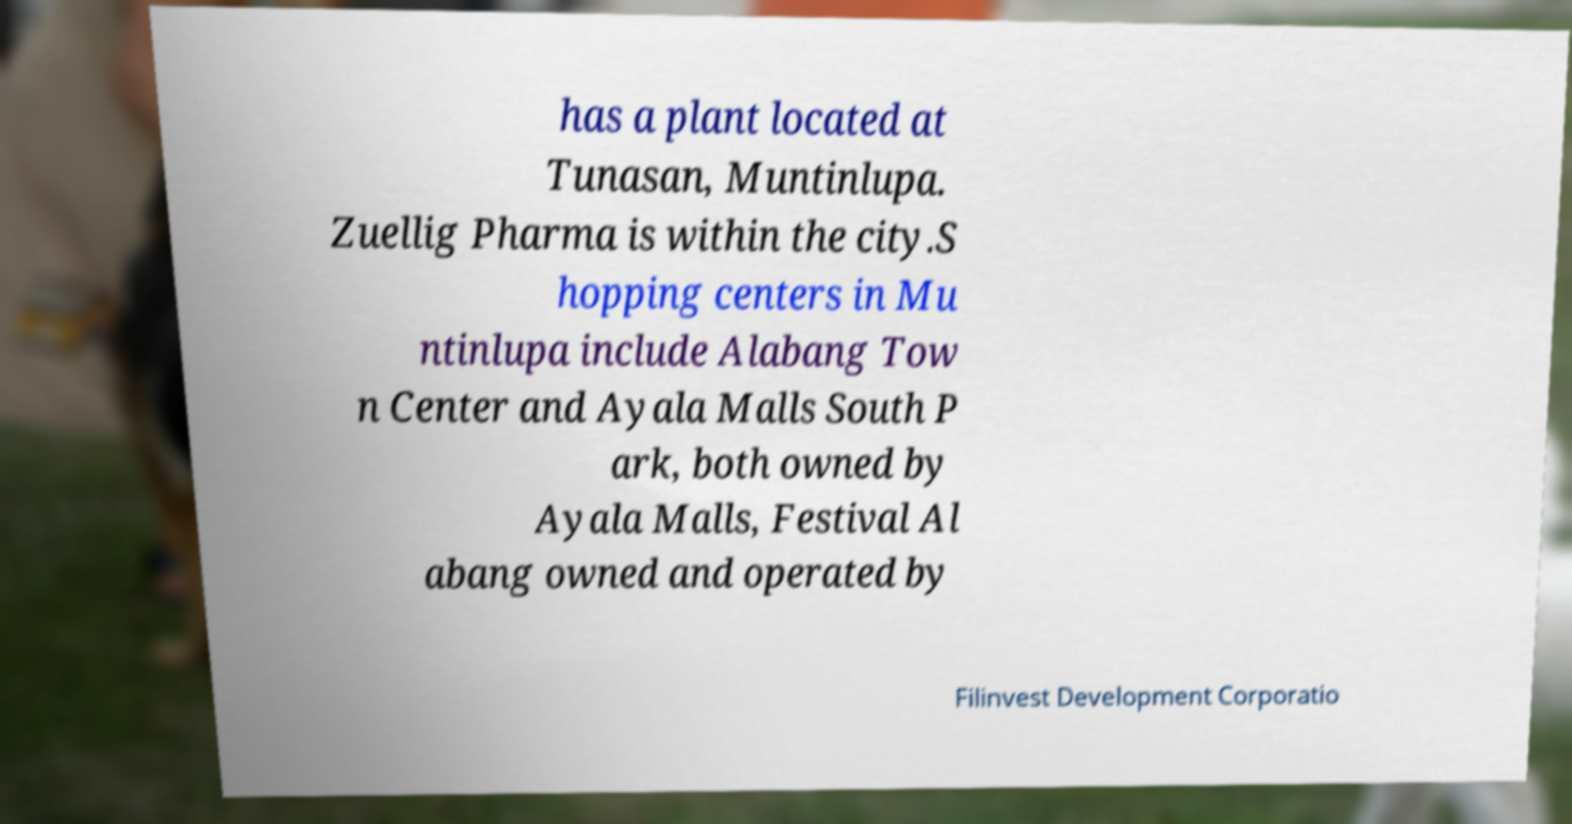For documentation purposes, I need the text within this image transcribed. Could you provide that? has a plant located at Tunasan, Muntinlupa. Zuellig Pharma is within the city.S hopping centers in Mu ntinlupa include Alabang Tow n Center and Ayala Malls South P ark, both owned by Ayala Malls, Festival Al abang owned and operated by Filinvest Development Corporatio 